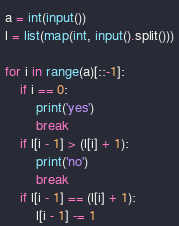Convert code to text. <code><loc_0><loc_0><loc_500><loc_500><_Python_>a = int(input())
l = list(map(int, input().split()))

for i in range(a)[::-1]:
    if i == 0:
        print('yes')
        break
    if l[i - 1] > (l[i] + 1):
        print('no')
        break
    if l[i - 1] == (l[i] + 1):
        l[i - 1] -= 1
</code> 